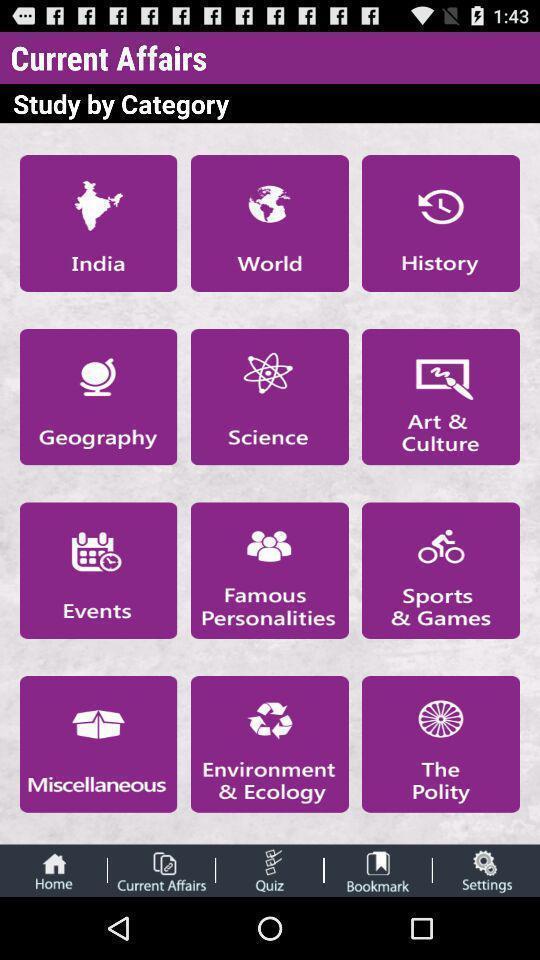Explain the elements present in this screenshot. Various categories of current affair. 